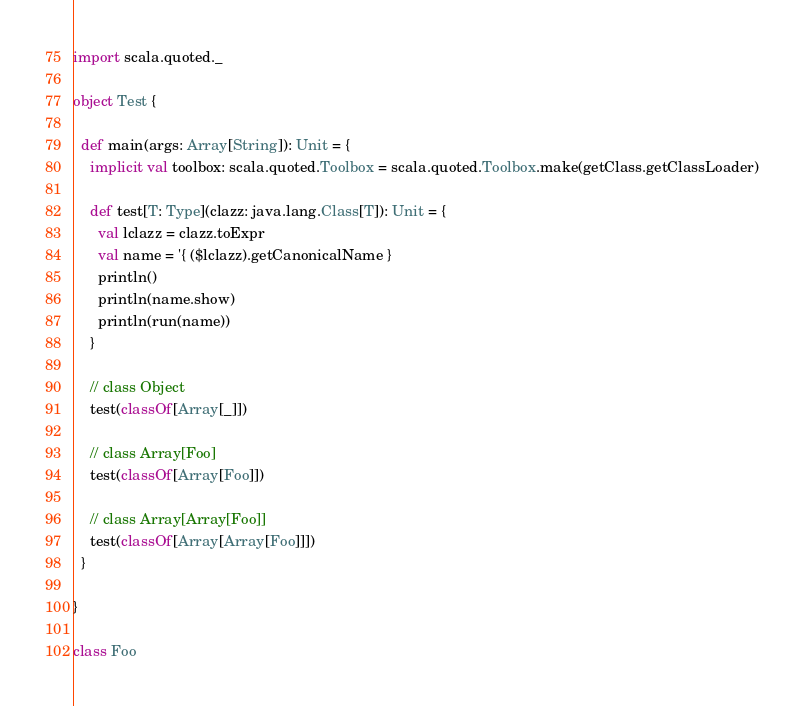<code> <loc_0><loc_0><loc_500><loc_500><_Scala_>
import scala.quoted._

object Test {

  def main(args: Array[String]): Unit = {
    implicit val toolbox: scala.quoted.Toolbox = scala.quoted.Toolbox.make(getClass.getClassLoader)

    def test[T: Type](clazz: java.lang.Class[T]): Unit = {
      val lclazz = clazz.toExpr
      val name = '{ ($lclazz).getCanonicalName }
      println()
      println(name.show)
      println(run(name))
    }

    // class Object
    test(classOf[Array[_]])

    // class Array[Foo]
    test(classOf[Array[Foo]])

    // class Array[Array[Foo]]
    test(classOf[Array[Array[Foo]]])
  }

}

class Foo
</code> 